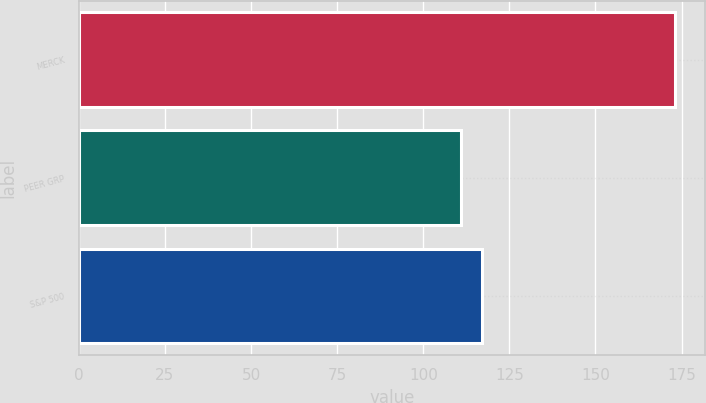Convert chart to OTSL. <chart><loc_0><loc_0><loc_500><loc_500><bar_chart><fcel>MERCK<fcel>PEER GRP<fcel>S&P 500<nl><fcel>173.1<fcel>110.83<fcel>117.06<nl></chart> 